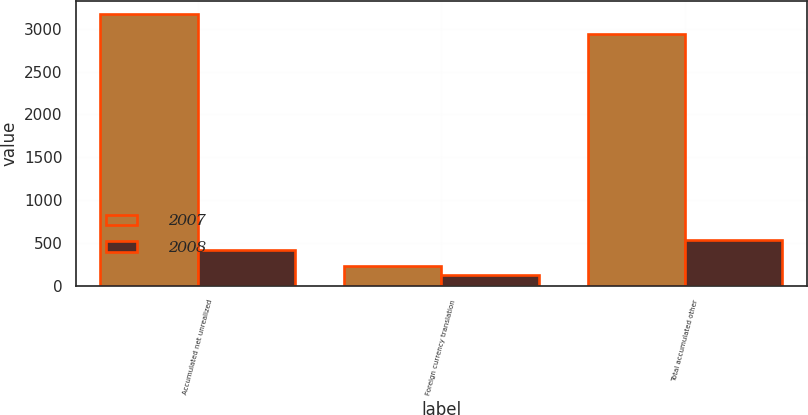Convert chart to OTSL. <chart><loc_0><loc_0><loc_500><loc_500><stacked_bar_chart><ecel><fcel>Accumulated net unrealized<fcel>Foreign currency translation<fcel>Total accumulated other<nl><fcel>2007<fcel>3170<fcel>227<fcel>2943<nl><fcel>2008<fcel>412<fcel>118<fcel>530<nl></chart> 